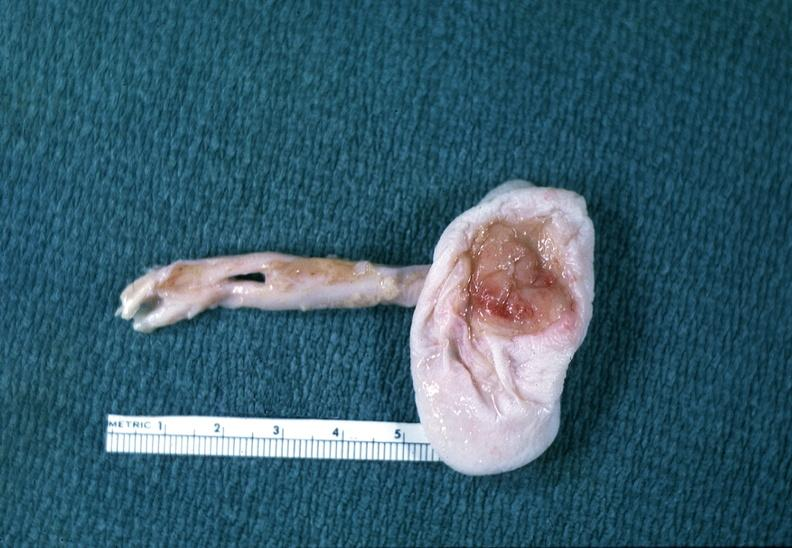what does this image show?
Answer the question using a single word or phrase. Neural tube defect 